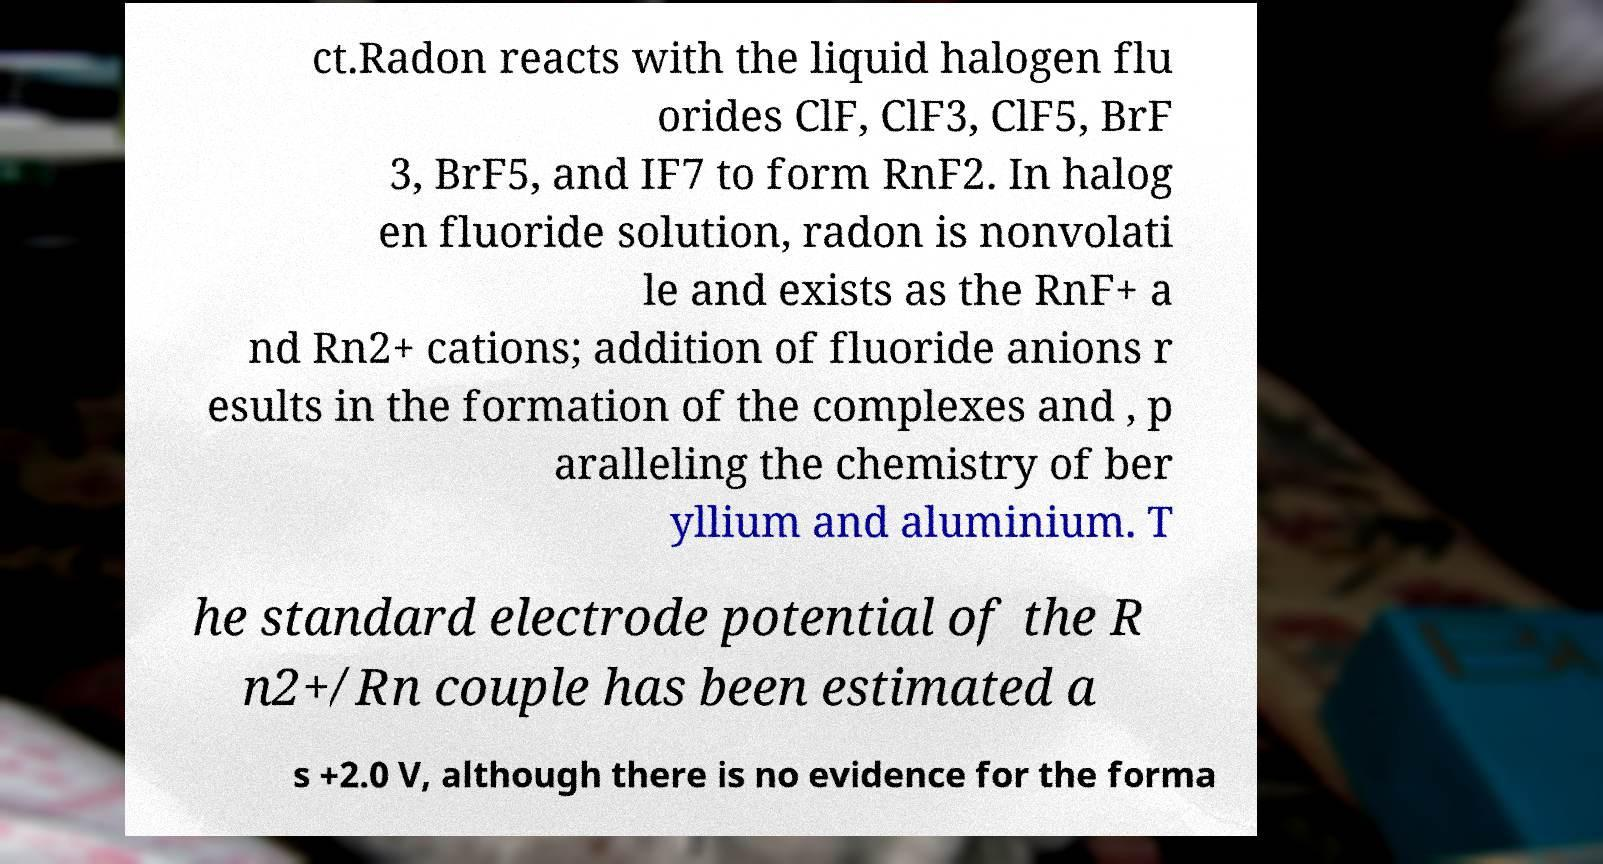I need the written content from this picture converted into text. Can you do that? ct.Radon reacts with the liquid halogen flu orides ClF, ClF3, ClF5, BrF 3, BrF5, and IF7 to form RnF2. In halog en fluoride solution, radon is nonvolati le and exists as the RnF+ a nd Rn2+ cations; addition of fluoride anions r esults in the formation of the complexes and , p aralleling the chemistry of ber yllium and aluminium. T he standard electrode potential of the R n2+/Rn couple has been estimated a s +2.0 V, although there is no evidence for the forma 